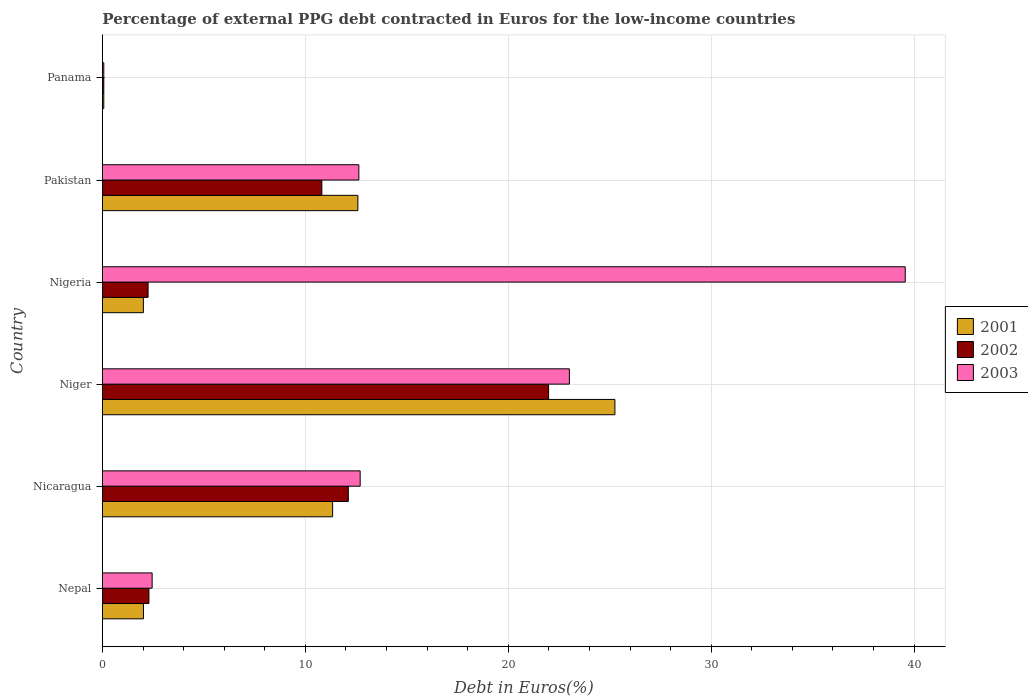How many groups of bars are there?
Your answer should be compact. 6. How many bars are there on the 4th tick from the bottom?
Your answer should be compact. 3. What is the label of the 6th group of bars from the top?
Your answer should be very brief. Nepal. In how many cases, is the number of bars for a given country not equal to the number of legend labels?
Offer a terse response. 0. What is the percentage of external PPG debt contracted in Euros in 2002 in Nigeria?
Offer a very short reply. 2.25. Across all countries, what is the maximum percentage of external PPG debt contracted in Euros in 2003?
Provide a short and direct response. 39.56. Across all countries, what is the minimum percentage of external PPG debt contracted in Euros in 2003?
Keep it short and to the point. 0.07. In which country was the percentage of external PPG debt contracted in Euros in 2002 maximum?
Your answer should be very brief. Niger. In which country was the percentage of external PPG debt contracted in Euros in 2001 minimum?
Ensure brevity in your answer.  Panama. What is the total percentage of external PPG debt contracted in Euros in 2003 in the graph?
Ensure brevity in your answer.  90.42. What is the difference between the percentage of external PPG debt contracted in Euros in 2001 in Nicaragua and that in Pakistan?
Provide a succinct answer. -1.24. What is the difference between the percentage of external PPG debt contracted in Euros in 2002 in Nepal and the percentage of external PPG debt contracted in Euros in 2001 in Nigeria?
Offer a very short reply. 0.27. What is the average percentage of external PPG debt contracted in Euros in 2002 per country?
Provide a short and direct response. 8.25. What is the difference between the percentage of external PPG debt contracted in Euros in 2003 and percentage of external PPG debt contracted in Euros in 2001 in Nigeria?
Make the answer very short. 37.54. What is the ratio of the percentage of external PPG debt contracted in Euros in 2003 in Pakistan to that in Panama?
Make the answer very short. 192.3. Is the percentage of external PPG debt contracted in Euros in 2003 in Nicaragua less than that in Nigeria?
Keep it short and to the point. Yes. Is the difference between the percentage of external PPG debt contracted in Euros in 2003 in Pakistan and Panama greater than the difference between the percentage of external PPG debt contracted in Euros in 2001 in Pakistan and Panama?
Provide a short and direct response. Yes. What is the difference between the highest and the second highest percentage of external PPG debt contracted in Euros in 2003?
Keep it short and to the point. 16.55. What is the difference between the highest and the lowest percentage of external PPG debt contracted in Euros in 2001?
Your response must be concise. 25.19. In how many countries, is the percentage of external PPG debt contracted in Euros in 2003 greater than the average percentage of external PPG debt contracted in Euros in 2003 taken over all countries?
Your answer should be very brief. 2. Is the sum of the percentage of external PPG debt contracted in Euros in 2002 in Nicaragua and Pakistan greater than the maximum percentage of external PPG debt contracted in Euros in 2001 across all countries?
Make the answer very short. No. What does the 1st bar from the top in Pakistan represents?
Your answer should be very brief. 2003. What does the 3rd bar from the bottom in Niger represents?
Offer a terse response. 2003. Does the graph contain any zero values?
Provide a short and direct response. No. Does the graph contain grids?
Ensure brevity in your answer.  Yes. What is the title of the graph?
Your answer should be compact. Percentage of external PPG debt contracted in Euros for the low-income countries. What is the label or title of the X-axis?
Keep it short and to the point. Debt in Euros(%). What is the Debt in Euros(%) in 2001 in Nepal?
Provide a succinct answer. 2.02. What is the Debt in Euros(%) of 2002 in Nepal?
Offer a very short reply. 2.29. What is the Debt in Euros(%) of 2003 in Nepal?
Your answer should be very brief. 2.45. What is the Debt in Euros(%) in 2001 in Nicaragua?
Offer a very short reply. 11.34. What is the Debt in Euros(%) in 2002 in Nicaragua?
Offer a terse response. 12.12. What is the Debt in Euros(%) in 2003 in Nicaragua?
Offer a very short reply. 12.7. What is the Debt in Euros(%) of 2001 in Niger?
Your answer should be very brief. 25.25. What is the Debt in Euros(%) in 2002 in Niger?
Provide a short and direct response. 21.99. What is the Debt in Euros(%) in 2003 in Niger?
Provide a short and direct response. 23.01. What is the Debt in Euros(%) in 2001 in Nigeria?
Ensure brevity in your answer.  2.02. What is the Debt in Euros(%) of 2002 in Nigeria?
Keep it short and to the point. 2.25. What is the Debt in Euros(%) in 2003 in Nigeria?
Your answer should be compact. 39.56. What is the Debt in Euros(%) of 2001 in Pakistan?
Offer a terse response. 12.59. What is the Debt in Euros(%) in 2002 in Pakistan?
Give a very brief answer. 10.81. What is the Debt in Euros(%) in 2003 in Pakistan?
Your answer should be compact. 12.63. What is the Debt in Euros(%) in 2001 in Panama?
Your response must be concise. 0.06. What is the Debt in Euros(%) of 2002 in Panama?
Your response must be concise. 0.07. What is the Debt in Euros(%) of 2003 in Panama?
Provide a succinct answer. 0.07. Across all countries, what is the maximum Debt in Euros(%) of 2001?
Your answer should be compact. 25.25. Across all countries, what is the maximum Debt in Euros(%) of 2002?
Offer a very short reply. 21.99. Across all countries, what is the maximum Debt in Euros(%) in 2003?
Provide a succinct answer. 39.56. Across all countries, what is the minimum Debt in Euros(%) in 2001?
Make the answer very short. 0.06. Across all countries, what is the minimum Debt in Euros(%) in 2002?
Provide a short and direct response. 0.07. Across all countries, what is the minimum Debt in Euros(%) of 2003?
Offer a terse response. 0.07. What is the total Debt in Euros(%) of 2001 in the graph?
Provide a short and direct response. 53.28. What is the total Debt in Euros(%) of 2002 in the graph?
Keep it short and to the point. 49.52. What is the total Debt in Euros(%) in 2003 in the graph?
Your answer should be compact. 90.42. What is the difference between the Debt in Euros(%) in 2001 in Nepal and that in Nicaragua?
Your response must be concise. -9.32. What is the difference between the Debt in Euros(%) of 2002 in Nepal and that in Nicaragua?
Your response must be concise. -9.83. What is the difference between the Debt in Euros(%) in 2003 in Nepal and that in Nicaragua?
Provide a succinct answer. -10.25. What is the difference between the Debt in Euros(%) of 2001 in Nepal and that in Niger?
Ensure brevity in your answer.  -23.23. What is the difference between the Debt in Euros(%) in 2002 in Nepal and that in Niger?
Your response must be concise. -19.7. What is the difference between the Debt in Euros(%) of 2003 in Nepal and that in Niger?
Give a very brief answer. -20.56. What is the difference between the Debt in Euros(%) in 2001 in Nepal and that in Nigeria?
Offer a terse response. 0. What is the difference between the Debt in Euros(%) of 2002 in Nepal and that in Nigeria?
Provide a short and direct response. 0.04. What is the difference between the Debt in Euros(%) of 2003 in Nepal and that in Nigeria?
Provide a short and direct response. -37.11. What is the difference between the Debt in Euros(%) in 2001 in Nepal and that in Pakistan?
Give a very brief answer. -10.57. What is the difference between the Debt in Euros(%) of 2002 in Nepal and that in Pakistan?
Offer a very short reply. -8.52. What is the difference between the Debt in Euros(%) of 2003 in Nepal and that in Pakistan?
Ensure brevity in your answer.  -10.19. What is the difference between the Debt in Euros(%) in 2001 in Nepal and that in Panama?
Your answer should be compact. 1.96. What is the difference between the Debt in Euros(%) of 2002 in Nepal and that in Panama?
Keep it short and to the point. 2.22. What is the difference between the Debt in Euros(%) in 2003 in Nepal and that in Panama?
Make the answer very short. 2.38. What is the difference between the Debt in Euros(%) of 2001 in Nicaragua and that in Niger?
Your response must be concise. -13.91. What is the difference between the Debt in Euros(%) of 2002 in Nicaragua and that in Niger?
Your answer should be compact. -9.87. What is the difference between the Debt in Euros(%) in 2003 in Nicaragua and that in Niger?
Keep it short and to the point. -10.31. What is the difference between the Debt in Euros(%) in 2001 in Nicaragua and that in Nigeria?
Offer a very short reply. 9.33. What is the difference between the Debt in Euros(%) in 2002 in Nicaragua and that in Nigeria?
Keep it short and to the point. 9.87. What is the difference between the Debt in Euros(%) in 2003 in Nicaragua and that in Nigeria?
Ensure brevity in your answer.  -26.86. What is the difference between the Debt in Euros(%) in 2001 in Nicaragua and that in Pakistan?
Give a very brief answer. -1.24. What is the difference between the Debt in Euros(%) in 2002 in Nicaragua and that in Pakistan?
Provide a short and direct response. 1.3. What is the difference between the Debt in Euros(%) in 2003 in Nicaragua and that in Pakistan?
Offer a very short reply. 0.07. What is the difference between the Debt in Euros(%) in 2001 in Nicaragua and that in Panama?
Ensure brevity in your answer.  11.28. What is the difference between the Debt in Euros(%) in 2002 in Nicaragua and that in Panama?
Provide a succinct answer. 12.05. What is the difference between the Debt in Euros(%) in 2003 in Nicaragua and that in Panama?
Give a very brief answer. 12.63. What is the difference between the Debt in Euros(%) of 2001 in Niger and that in Nigeria?
Provide a succinct answer. 23.24. What is the difference between the Debt in Euros(%) of 2002 in Niger and that in Nigeria?
Your answer should be compact. 19.74. What is the difference between the Debt in Euros(%) of 2003 in Niger and that in Nigeria?
Offer a terse response. -16.55. What is the difference between the Debt in Euros(%) in 2001 in Niger and that in Pakistan?
Provide a succinct answer. 12.67. What is the difference between the Debt in Euros(%) in 2002 in Niger and that in Pakistan?
Keep it short and to the point. 11.17. What is the difference between the Debt in Euros(%) in 2003 in Niger and that in Pakistan?
Your answer should be compact. 10.38. What is the difference between the Debt in Euros(%) of 2001 in Niger and that in Panama?
Offer a terse response. 25.19. What is the difference between the Debt in Euros(%) of 2002 in Niger and that in Panama?
Offer a very short reply. 21.92. What is the difference between the Debt in Euros(%) in 2003 in Niger and that in Panama?
Your response must be concise. 22.94. What is the difference between the Debt in Euros(%) in 2001 in Nigeria and that in Pakistan?
Give a very brief answer. -10.57. What is the difference between the Debt in Euros(%) in 2002 in Nigeria and that in Pakistan?
Keep it short and to the point. -8.56. What is the difference between the Debt in Euros(%) in 2003 in Nigeria and that in Pakistan?
Make the answer very short. 26.93. What is the difference between the Debt in Euros(%) in 2001 in Nigeria and that in Panama?
Provide a succinct answer. 1.95. What is the difference between the Debt in Euros(%) of 2002 in Nigeria and that in Panama?
Provide a short and direct response. 2.18. What is the difference between the Debt in Euros(%) of 2003 in Nigeria and that in Panama?
Keep it short and to the point. 39.49. What is the difference between the Debt in Euros(%) in 2001 in Pakistan and that in Panama?
Offer a terse response. 12.52. What is the difference between the Debt in Euros(%) in 2002 in Pakistan and that in Panama?
Ensure brevity in your answer.  10.75. What is the difference between the Debt in Euros(%) of 2003 in Pakistan and that in Panama?
Keep it short and to the point. 12.57. What is the difference between the Debt in Euros(%) in 2001 in Nepal and the Debt in Euros(%) in 2002 in Nicaragua?
Ensure brevity in your answer.  -10.09. What is the difference between the Debt in Euros(%) of 2001 in Nepal and the Debt in Euros(%) of 2003 in Nicaragua?
Give a very brief answer. -10.68. What is the difference between the Debt in Euros(%) of 2002 in Nepal and the Debt in Euros(%) of 2003 in Nicaragua?
Keep it short and to the point. -10.41. What is the difference between the Debt in Euros(%) in 2001 in Nepal and the Debt in Euros(%) in 2002 in Niger?
Your response must be concise. -19.96. What is the difference between the Debt in Euros(%) of 2001 in Nepal and the Debt in Euros(%) of 2003 in Niger?
Make the answer very short. -20.99. What is the difference between the Debt in Euros(%) of 2002 in Nepal and the Debt in Euros(%) of 2003 in Niger?
Ensure brevity in your answer.  -20.72. What is the difference between the Debt in Euros(%) in 2001 in Nepal and the Debt in Euros(%) in 2002 in Nigeria?
Offer a terse response. -0.23. What is the difference between the Debt in Euros(%) in 2001 in Nepal and the Debt in Euros(%) in 2003 in Nigeria?
Give a very brief answer. -37.54. What is the difference between the Debt in Euros(%) of 2002 in Nepal and the Debt in Euros(%) of 2003 in Nigeria?
Make the answer very short. -37.27. What is the difference between the Debt in Euros(%) of 2001 in Nepal and the Debt in Euros(%) of 2002 in Pakistan?
Give a very brief answer. -8.79. What is the difference between the Debt in Euros(%) of 2001 in Nepal and the Debt in Euros(%) of 2003 in Pakistan?
Ensure brevity in your answer.  -10.61. What is the difference between the Debt in Euros(%) in 2002 in Nepal and the Debt in Euros(%) in 2003 in Pakistan?
Your answer should be very brief. -10.34. What is the difference between the Debt in Euros(%) in 2001 in Nepal and the Debt in Euros(%) in 2002 in Panama?
Your answer should be very brief. 1.96. What is the difference between the Debt in Euros(%) of 2001 in Nepal and the Debt in Euros(%) of 2003 in Panama?
Keep it short and to the point. 1.96. What is the difference between the Debt in Euros(%) in 2002 in Nepal and the Debt in Euros(%) in 2003 in Panama?
Provide a succinct answer. 2.22. What is the difference between the Debt in Euros(%) in 2001 in Nicaragua and the Debt in Euros(%) in 2002 in Niger?
Provide a short and direct response. -10.64. What is the difference between the Debt in Euros(%) in 2001 in Nicaragua and the Debt in Euros(%) in 2003 in Niger?
Your response must be concise. -11.67. What is the difference between the Debt in Euros(%) of 2002 in Nicaragua and the Debt in Euros(%) of 2003 in Niger?
Your answer should be compact. -10.89. What is the difference between the Debt in Euros(%) of 2001 in Nicaragua and the Debt in Euros(%) of 2002 in Nigeria?
Provide a succinct answer. 9.09. What is the difference between the Debt in Euros(%) of 2001 in Nicaragua and the Debt in Euros(%) of 2003 in Nigeria?
Provide a succinct answer. -28.22. What is the difference between the Debt in Euros(%) of 2002 in Nicaragua and the Debt in Euros(%) of 2003 in Nigeria?
Provide a succinct answer. -27.44. What is the difference between the Debt in Euros(%) of 2001 in Nicaragua and the Debt in Euros(%) of 2002 in Pakistan?
Provide a succinct answer. 0.53. What is the difference between the Debt in Euros(%) of 2001 in Nicaragua and the Debt in Euros(%) of 2003 in Pakistan?
Keep it short and to the point. -1.29. What is the difference between the Debt in Euros(%) in 2002 in Nicaragua and the Debt in Euros(%) in 2003 in Pakistan?
Ensure brevity in your answer.  -0.52. What is the difference between the Debt in Euros(%) of 2001 in Nicaragua and the Debt in Euros(%) of 2002 in Panama?
Offer a terse response. 11.28. What is the difference between the Debt in Euros(%) of 2001 in Nicaragua and the Debt in Euros(%) of 2003 in Panama?
Provide a short and direct response. 11.28. What is the difference between the Debt in Euros(%) of 2002 in Nicaragua and the Debt in Euros(%) of 2003 in Panama?
Make the answer very short. 12.05. What is the difference between the Debt in Euros(%) of 2001 in Niger and the Debt in Euros(%) of 2002 in Nigeria?
Your response must be concise. 23.01. What is the difference between the Debt in Euros(%) in 2001 in Niger and the Debt in Euros(%) in 2003 in Nigeria?
Keep it short and to the point. -14.31. What is the difference between the Debt in Euros(%) in 2002 in Niger and the Debt in Euros(%) in 2003 in Nigeria?
Ensure brevity in your answer.  -17.57. What is the difference between the Debt in Euros(%) of 2001 in Niger and the Debt in Euros(%) of 2002 in Pakistan?
Give a very brief answer. 14.44. What is the difference between the Debt in Euros(%) in 2001 in Niger and the Debt in Euros(%) in 2003 in Pakistan?
Make the answer very short. 12.62. What is the difference between the Debt in Euros(%) in 2002 in Niger and the Debt in Euros(%) in 2003 in Pakistan?
Make the answer very short. 9.35. What is the difference between the Debt in Euros(%) of 2001 in Niger and the Debt in Euros(%) of 2002 in Panama?
Your answer should be compact. 25.19. What is the difference between the Debt in Euros(%) in 2001 in Niger and the Debt in Euros(%) in 2003 in Panama?
Provide a short and direct response. 25.19. What is the difference between the Debt in Euros(%) of 2002 in Niger and the Debt in Euros(%) of 2003 in Panama?
Provide a short and direct response. 21.92. What is the difference between the Debt in Euros(%) of 2001 in Nigeria and the Debt in Euros(%) of 2002 in Pakistan?
Your answer should be very brief. -8.8. What is the difference between the Debt in Euros(%) in 2001 in Nigeria and the Debt in Euros(%) in 2003 in Pakistan?
Make the answer very short. -10.62. What is the difference between the Debt in Euros(%) of 2002 in Nigeria and the Debt in Euros(%) of 2003 in Pakistan?
Your answer should be compact. -10.39. What is the difference between the Debt in Euros(%) of 2001 in Nigeria and the Debt in Euros(%) of 2002 in Panama?
Provide a succinct answer. 1.95. What is the difference between the Debt in Euros(%) of 2001 in Nigeria and the Debt in Euros(%) of 2003 in Panama?
Provide a short and direct response. 1.95. What is the difference between the Debt in Euros(%) in 2002 in Nigeria and the Debt in Euros(%) in 2003 in Panama?
Your response must be concise. 2.18. What is the difference between the Debt in Euros(%) of 2001 in Pakistan and the Debt in Euros(%) of 2002 in Panama?
Offer a terse response. 12.52. What is the difference between the Debt in Euros(%) in 2001 in Pakistan and the Debt in Euros(%) in 2003 in Panama?
Your answer should be very brief. 12.52. What is the difference between the Debt in Euros(%) of 2002 in Pakistan and the Debt in Euros(%) of 2003 in Panama?
Make the answer very short. 10.75. What is the average Debt in Euros(%) in 2001 per country?
Give a very brief answer. 8.88. What is the average Debt in Euros(%) of 2002 per country?
Provide a short and direct response. 8.25. What is the average Debt in Euros(%) of 2003 per country?
Your answer should be compact. 15.07. What is the difference between the Debt in Euros(%) of 2001 and Debt in Euros(%) of 2002 in Nepal?
Make the answer very short. -0.27. What is the difference between the Debt in Euros(%) of 2001 and Debt in Euros(%) of 2003 in Nepal?
Provide a short and direct response. -0.43. What is the difference between the Debt in Euros(%) of 2002 and Debt in Euros(%) of 2003 in Nepal?
Keep it short and to the point. -0.16. What is the difference between the Debt in Euros(%) of 2001 and Debt in Euros(%) of 2002 in Nicaragua?
Give a very brief answer. -0.77. What is the difference between the Debt in Euros(%) in 2001 and Debt in Euros(%) in 2003 in Nicaragua?
Keep it short and to the point. -1.36. What is the difference between the Debt in Euros(%) in 2002 and Debt in Euros(%) in 2003 in Nicaragua?
Ensure brevity in your answer.  -0.58. What is the difference between the Debt in Euros(%) in 2001 and Debt in Euros(%) in 2002 in Niger?
Offer a terse response. 3.27. What is the difference between the Debt in Euros(%) of 2001 and Debt in Euros(%) of 2003 in Niger?
Ensure brevity in your answer.  2.24. What is the difference between the Debt in Euros(%) of 2002 and Debt in Euros(%) of 2003 in Niger?
Offer a very short reply. -1.02. What is the difference between the Debt in Euros(%) of 2001 and Debt in Euros(%) of 2002 in Nigeria?
Offer a terse response. -0.23. What is the difference between the Debt in Euros(%) of 2001 and Debt in Euros(%) of 2003 in Nigeria?
Provide a succinct answer. -37.54. What is the difference between the Debt in Euros(%) in 2002 and Debt in Euros(%) in 2003 in Nigeria?
Give a very brief answer. -37.31. What is the difference between the Debt in Euros(%) in 2001 and Debt in Euros(%) in 2002 in Pakistan?
Offer a very short reply. 1.77. What is the difference between the Debt in Euros(%) of 2001 and Debt in Euros(%) of 2003 in Pakistan?
Ensure brevity in your answer.  -0.05. What is the difference between the Debt in Euros(%) of 2002 and Debt in Euros(%) of 2003 in Pakistan?
Offer a terse response. -1.82. What is the difference between the Debt in Euros(%) in 2001 and Debt in Euros(%) in 2002 in Panama?
Provide a succinct answer. -0. What is the difference between the Debt in Euros(%) of 2001 and Debt in Euros(%) of 2003 in Panama?
Give a very brief answer. -0. What is the ratio of the Debt in Euros(%) in 2001 in Nepal to that in Nicaragua?
Provide a succinct answer. 0.18. What is the ratio of the Debt in Euros(%) in 2002 in Nepal to that in Nicaragua?
Offer a terse response. 0.19. What is the ratio of the Debt in Euros(%) of 2003 in Nepal to that in Nicaragua?
Your answer should be very brief. 0.19. What is the ratio of the Debt in Euros(%) in 2002 in Nepal to that in Niger?
Provide a succinct answer. 0.1. What is the ratio of the Debt in Euros(%) in 2003 in Nepal to that in Niger?
Offer a terse response. 0.11. What is the ratio of the Debt in Euros(%) in 2002 in Nepal to that in Nigeria?
Keep it short and to the point. 1.02. What is the ratio of the Debt in Euros(%) of 2003 in Nepal to that in Nigeria?
Provide a short and direct response. 0.06. What is the ratio of the Debt in Euros(%) of 2001 in Nepal to that in Pakistan?
Your answer should be compact. 0.16. What is the ratio of the Debt in Euros(%) in 2002 in Nepal to that in Pakistan?
Give a very brief answer. 0.21. What is the ratio of the Debt in Euros(%) of 2003 in Nepal to that in Pakistan?
Give a very brief answer. 0.19. What is the ratio of the Debt in Euros(%) in 2001 in Nepal to that in Panama?
Your answer should be very brief. 31.14. What is the ratio of the Debt in Euros(%) of 2002 in Nepal to that in Panama?
Your answer should be compact. 34.84. What is the ratio of the Debt in Euros(%) of 2003 in Nepal to that in Panama?
Your answer should be compact. 37.26. What is the ratio of the Debt in Euros(%) in 2001 in Nicaragua to that in Niger?
Your response must be concise. 0.45. What is the ratio of the Debt in Euros(%) in 2002 in Nicaragua to that in Niger?
Offer a very short reply. 0.55. What is the ratio of the Debt in Euros(%) of 2003 in Nicaragua to that in Niger?
Ensure brevity in your answer.  0.55. What is the ratio of the Debt in Euros(%) in 2001 in Nicaragua to that in Nigeria?
Your answer should be compact. 5.63. What is the ratio of the Debt in Euros(%) of 2002 in Nicaragua to that in Nigeria?
Offer a terse response. 5.39. What is the ratio of the Debt in Euros(%) of 2003 in Nicaragua to that in Nigeria?
Your answer should be very brief. 0.32. What is the ratio of the Debt in Euros(%) of 2001 in Nicaragua to that in Pakistan?
Offer a terse response. 0.9. What is the ratio of the Debt in Euros(%) of 2002 in Nicaragua to that in Pakistan?
Provide a short and direct response. 1.12. What is the ratio of the Debt in Euros(%) of 2003 in Nicaragua to that in Pakistan?
Offer a very short reply. 1.01. What is the ratio of the Debt in Euros(%) of 2001 in Nicaragua to that in Panama?
Your answer should be very brief. 174.76. What is the ratio of the Debt in Euros(%) of 2002 in Nicaragua to that in Panama?
Provide a succinct answer. 184.41. What is the ratio of the Debt in Euros(%) in 2003 in Nicaragua to that in Panama?
Offer a very short reply. 193.29. What is the ratio of the Debt in Euros(%) in 2001 in Niger to that in Nigeria?
Keep it short and to the point. 12.53. What is the ratio of the Debt in Euros(%) in 2002 in Niger to that in Nigeria?
Offer a terse response. 9.78. What is the ratio of the Debt in Euros(%) in 2003 in Niger to that in Nigeria?
Keep it short and to the point. 0.58. What is the ratio of the Debt in Euros(%) in 2001 in Niger to that in Pakistan?
Offer a terse response. 2.01. What is the ratio of the Debt in Euros(%) of 2002 in Niger to that in Pakistan?
Make the answer very short. 2.03. What is the ratio of the Debt in Euros(%) in 2003 in Niger to that in Pakistan?
Make the answer very short. 1.82. What is the ratio of the Debt in Euros(%) in 2001 in Niger to that in Panama?
Your answer should be compact. 389.1. What is the ratio of the Debt in Euros(%) in 2002 in Niger to that in Panama?
Give a very brief answer. 334.63. What is the ratio of the Debt in Euros(%) in 2003 in Niger to that in Panama?
Your answer should be compact. 350.22. What is the ratio of the Debt in Euros(%) in 2001 in Nigeria to that in Pakistan?
Provide a succinct answer. 0.16. What is the ratio of the Debt in Euros(%) in 2002 in Nigeria to that in Pakistan?
Provide a short and direct response. 0.21. What is the ratio of the Debt in Euros(%) in 2003 in Nigeria to that in Pakistan?
Offer a very short reply. 3.13. What is the ratio of the Debt in Euros(%) in 2001 in Nigeria to that in Panama?
Ensure brevity in your answer.  31.06. What is the ratio of the Debt in Euros(%) of 2002 in Nigeria to that in Panama?
Give a very brief answer. 34.21. What is the ratio of the Debt in Euros(%) in 2003 in Nigeria to that in Panama?
Keep it short and to the point. 602.13. What is the ratio of the Debt in Euros(%) of 2001 in Pakistan to that in Panama?
Your response must be concise. 193.94. What is the ratio of the Debt in Euros(%) in 2002 in Pakistan to that in Panama?
Provide a short and direct response. 164.57. What is the ratio of the Debt in Euros(%) of 2003 in Pakistan to that in Panama?
Ensure brevity in your answer.  192.3. What is the difference between the highest and the second highest Debt in Euros(%) in 2001?
Offer a terse response. 12.67. What is the difference between the highest and the second highest Debt in Euros(%) of 2002?
Make the answer very short. 9.87. What is the difference between the highest and the second highest Debt in Euros(%) of 2003?
Your answer should be very brief. 16.55. What is the difference between the highest and the lowest Debt in Euros(%) of 2001?
Your answer should be very brief. 25.19. What is the difference between the highest and the lowest Debt in Euros(%) in 2002?
Give a very brief answer. 21.92. What is the difference between the highest and the lowest Debt in Euros(%) of 2003?
Ensure brevity in your answer.  39.49. 